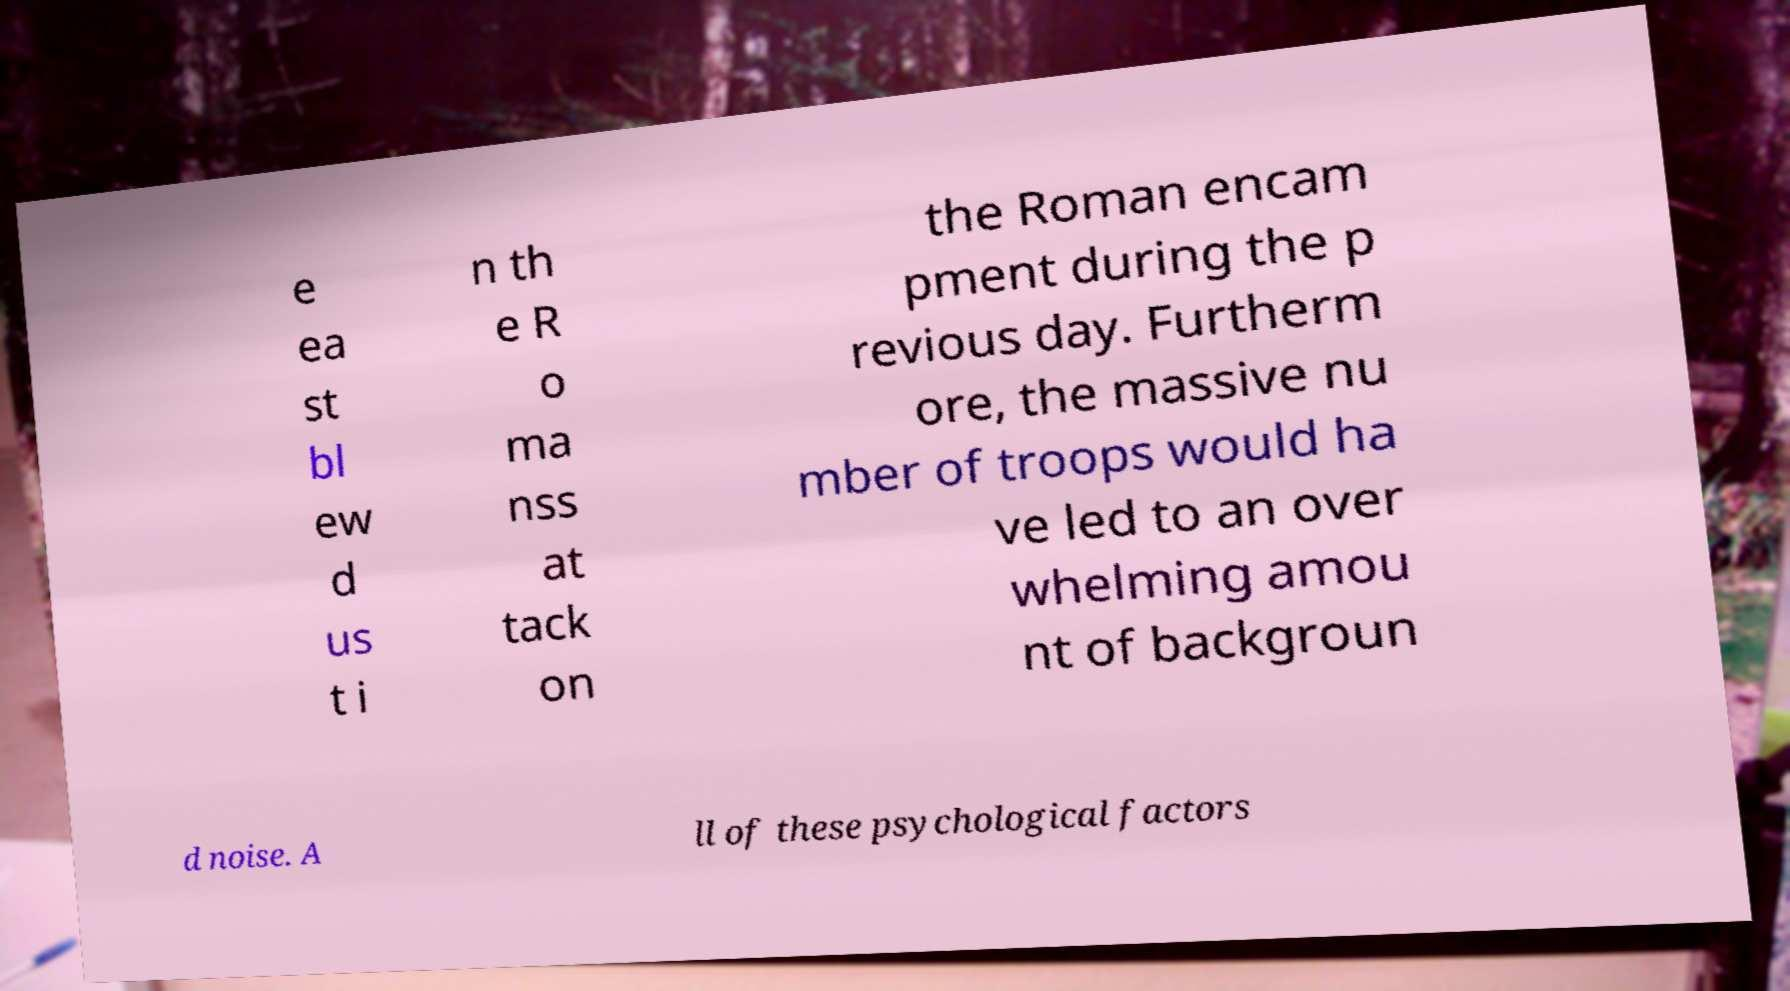Please identify and transcribe the text found in this image. e ea st bl ew d us t i n th e R o ma nss at tack on the Roman encam pment during the p revious day. Furtherm ore, the massive nu mber of troops would ha ve led to an over whelming amou nt of backgroun d noise. A ll of these psychological factors 